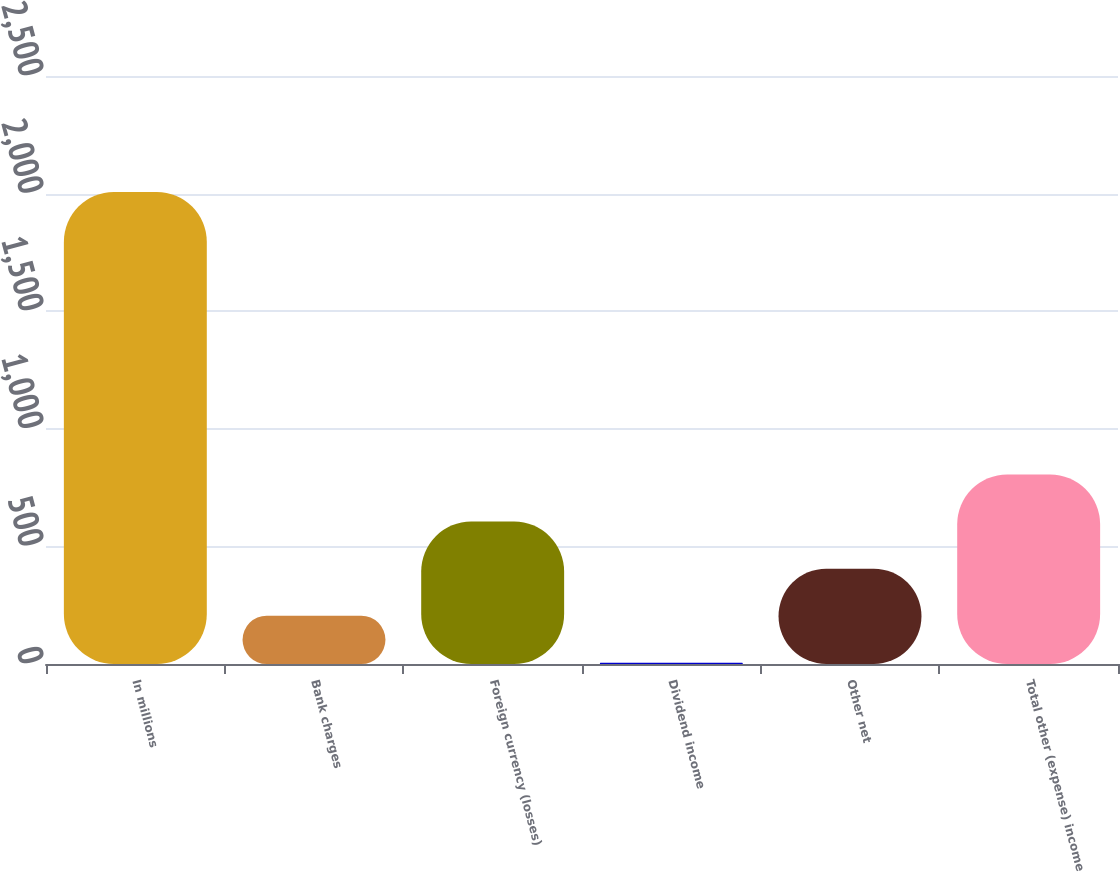Convert chart to OTSL. <chart><loc_0><loc_0><loc_500><loc_500><bar_chart><fcel>In millions<fcel>Bank charges<fcel>Foreign currency (losses)<fcel>Dividend income<fcel>Other net<fcel>Total other (expense) income<nl><fcel>2007<fcel>205.2<fcel>605.6<fcel>5<fcel>405.4<fcel>805.8<nl></chart> 